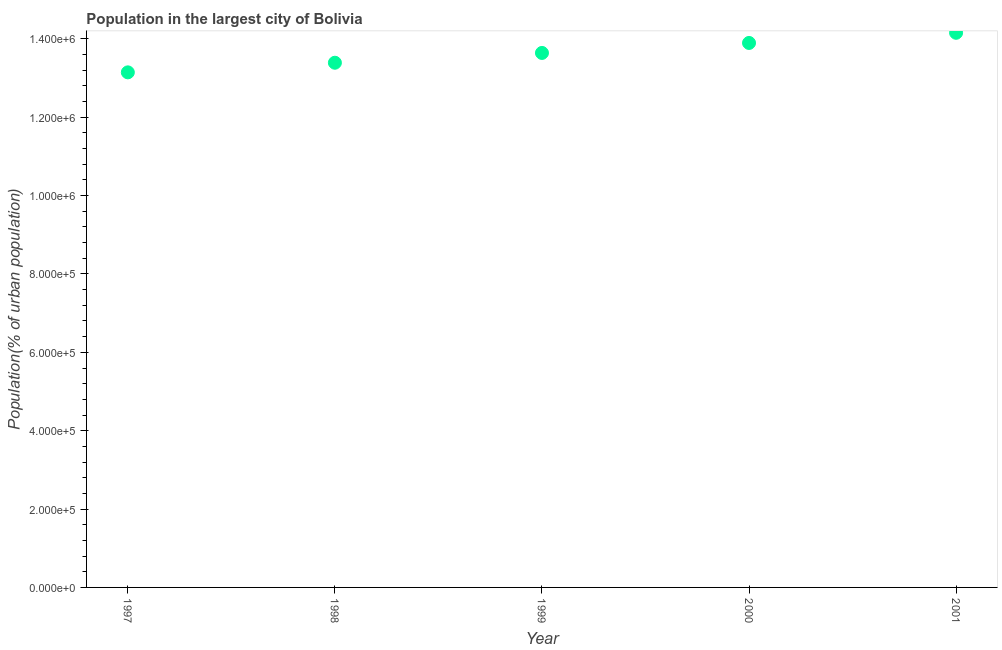What is the population in largest city in 1998?
Make the answer very short. 1.34e+06. Across all years, what is the maximum population in largest city?
Make the answer very short. 1.42e+06. Across all years, what is the minimum population in largest city?
Provide a short and direct response. 1.31e+06. In which year was the population in largest city maximum?
Your response must be concise. 2001. In which year was the population in largest city minimum?
Make the answer very short. 1997. What is the sum of the population in largest city?
Make the answer very short. 6.82e+06. What is the difference between the population in largest city in 1997 and 1999?
Provide a succinct answer. -4.95e+04. What is the average population in largest city per year?
Your answer should be very brief. 1.36e+06. What is the median population in largest city?
Your answer should be compact. 1.36e+06. Do a majority of the years between 2001 and 1997 (inclusive) have population in largest city greater than 1000000 %?
Give a very brief answer. Yes. What is the ratio of the population in largest city in 1998 to that in 1999?
Offer a terse response. 0.98. Is the population in largest city in 1998 less than that in 2001?
Keep it short and to the point. Yes. Is the difference between the population in largest city in 1998 and 2001 greater than the difference between any two years?
Offer a terse response. No. What is the difference between the highest and the second highest population in largest city?
Your answer should be very brief. 2.59e+04. Is the sum of the population in largest city in 1998 and 1999 greater than the maximum population in largest city across all years?
Keep it short and to the point. Yes. What is the difference between the highest and the lowest population in largest city?
Give a very brief answer. 1.01e+05. In how many years, is the population in largest city greater than the average population in largest city taken over all years?
Your answer should be compact. 2. How many dotlines are there?
Your response must be concise. 1. Are the values on the major ticks of Y-axis written in scientific E-notation?
Your answer should be compact. Yes. Does the graph contain any zero values?
Make the answer very short. No. Does the graph contain grids?
Your answer should be very brief. No. What is the title of the graph?
Provide a short and direct response. Population in the largest city of Bolivia. What is the label or title of the X-axis?
Your answer should be compact. Year. What is the label or title of the Y-axis?
Give a very brief answer. Population(% of urban population). What is the Population(% of urban population) in 1997?
Your response must be concise. 1.31e+06. What is the Population(% of urban population) in 1998?
Make the answer very short. 1.34e+06. What is the Population(% of urban population) in 1999?
Keep it short and to the point. 1.36e+06. What is the Population(% of urban population) in 2000?
Your answer should be very brief. 1.39e+06. What is the Population(% of urban population) in 2001?
Keep it short and to the point. 1.42e+06. What is the difference between the Population(% of urban population) in 1997 and 1998?
Provide a short and direct response. -2.45e+04. What is the difference between the Population(% of urban population) in 1997 and 1999?
Make the answer very short. -4.95e+04. What is the difference between the Population(% of urban population) in 1997 and 2000?
Provide a succinct answer. -7.50e+04. What is the difference between the Population(% of urban population) in 1997 and 2001?
Offer a terse response. -1.01e+05. What is the difference between the Population(% of urban population) in 1998 and 1999?
Give a very brief answer. -2.50e+04. What is the difference between the Population(% of urban population) in 1998 and 2000?
Give a very brief answer. -5.05e+04. What is the difference between the Population(% of urban population) in 1998 and 2001?
Provide a succinct answer. -7.64e+04. What is the difference between the Population(% of urban population) in 1999 and 2000?
Your response must be concise. -2.55e+04. What is the difference between the Population(% of urban population) in 1999 and 2001?
Your answer should be very brief. -5.14e+04. What is the difference between the Population(% of urban population) in 2000 and 2001?
Your answer should be compact. -2.59e+04. What is the ratio of the Population(% of urban population) in 1997 to that in 1998?
Provide a succinct answer. 0.98. What is the ratio of the Population(% of urban population) in 1997 to that in 2000?
Give a very brief answer. 0.95. What is the ratio of the Population(% of urban population) in 1997 to that in 2001?
Offer a very short reply. 0.93. What is the ratio of the Population(% of urban population) in 1998 to that in 2001?
Offer a very short reply. 0.95. What is the ratio of the Population(% of urban population) in 1999 to that in 2000?
Give a very brief answer. 0.98. What is the ratio of the Population(% of urban population) in 1999 to that in 2001?
Offer a terse response. 0.96. What is the ratio of the Population(% of urban population) in 2000 to that in 2001?
Provide a short and direct response. 0.98. 